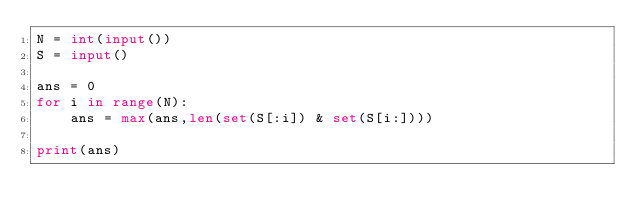<code> <loc_0><loc_0><loc_500><loc_500><_Python_>N = int(input())
S = input()

ans = 0
for i in range(N):
    ans = max(ans,len(set(S[:i]) & set(S[i:])))

print(ans)
</code> 